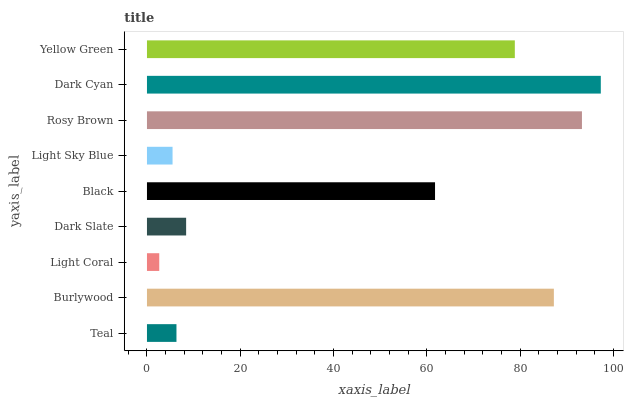Is Light Coral the minimum?
Answer yes or no. Yes. Is Dark Cyan the maximum?
Answer yes or no. Yes. Is Burlywood the minimum?
Answer yes or no. No. Is Burlywood the maximum?
Answer yes or no. No. Is Burlywood greater than Teal?
Answer yes or no. Yes. Is Teal less than Burlywood?
Answer yes or no. Yes. Is Teal greater than Burlywood?
Answer yes or no. No. Is Burlywood less than Teal?
Answer yes or no. No. Is Black the high median?
Answer yes or no. Yes. Is Black the low median?
Answer yes or no. Yes. Is Light Sky Blue the high median?
Answer yes or no. No. Is Yellow Green the low median?
Answer yes or no. No. 